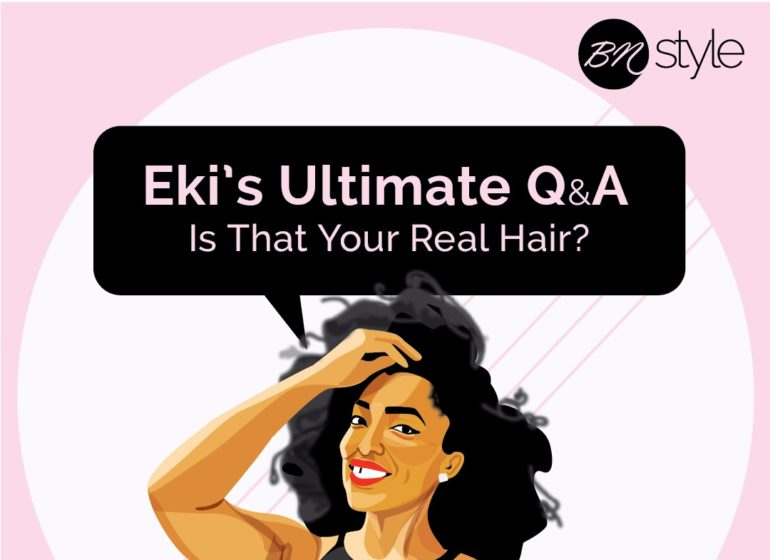What kind of topics can viewers expect from "Eki's Ultimate Q&A"? Viewers can expect a variety of engaging topics from "Eki's Ultimate Q&A." Primarily, the discussions will likely revolve around beauty and hair care with a strong emphasis on natural hair. Topics could include tips for maintaining natural hair, product recommendations, personal haircare routines, and discussions on embracing and celebrating natural beauty. The caption "Is That Your Real Hair?" suggests that the show might also explore issues related to hair authenticity and self-identity. What specific tips might be covered in a segment about maintaining natural hair? A segment about maintaining natural hair on "Eki's Ultimate Q&A" might cover tips such as the importance of regular moisturizing and deep conditioning to keep natural hair hydrated and healthy. It could include advice on using sulfate-free shampoos to avoid stripping away natural oils, protective styling options to minimize damage, and the benefits of regular trimming to prevent split ends. Additionally, the segment might discuss the use of natural oils like coconut, argan, and jojoba oil to nourish the hair and scalp, as well as the significance of a balanced diet in promoting healthy hair growth.  Imagine a whimsical scenario involving the woman in the image. What might that look like? In a whimsical scenario, the woman in the image might find herself in a magical forest where every tree, flower, and creature has a unique and vibrant hairstyle. As she walks through the enchanting forest, she encounters a wise old tree with flowing, silver hair who tells her that she has been chosen to discover the secret of the enchanted hair elixir. Along the way, she meets a talking bunny with rainbow fur, a deer with delicate, vine-like braids, and a flock of birds whose feathers change colors like a kaleidoscope. Each creature shares a piece of haircare wisdom with her, and by the end of her journey, she creates the ultimate haircare potion that ensures healthy, radiant hair for everyone in her village. 